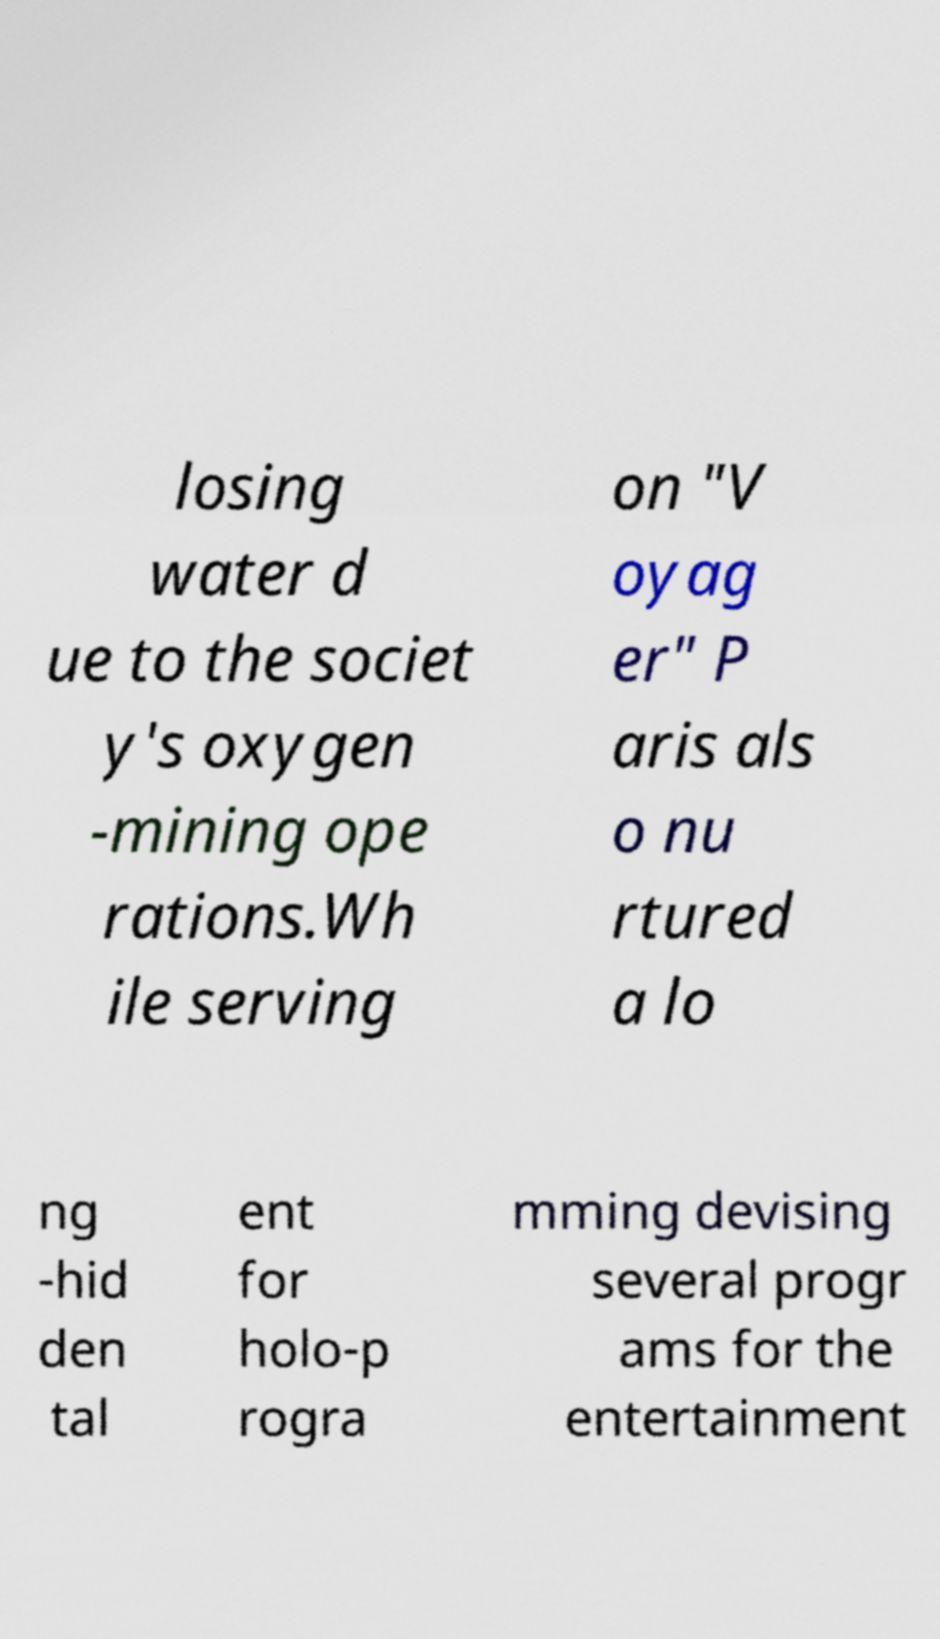Could you assist in decoding the text presented in this image and type it out clearly? losing water d ue to the societ y's oxygen -mining ope rations.Wh ile serving on "V oyag er" P aris als o nu rtured a lo ng -hid den tal ent for holo-p rogra mming devising several progr ams for the entertainment 